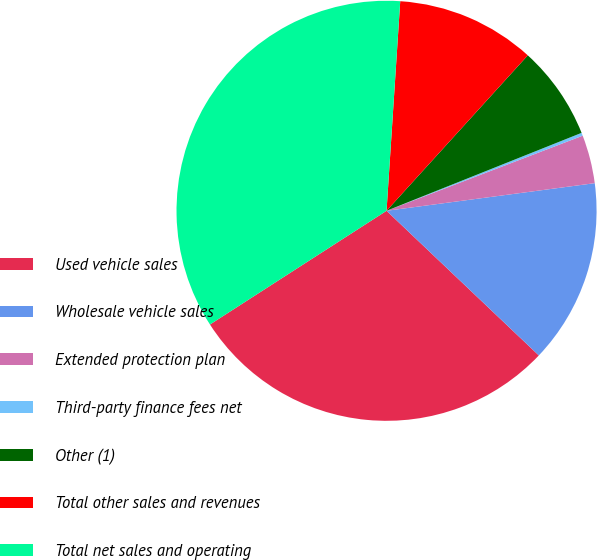<chart> <loc_0><loc_0><loc_500><loc_500><pie_chart><fcel>Used vehicle sales<fcel>Wholesale vehicle sales<fcel>Extended protection plan<fcel>Third-party finance fees net<fcel>Other (1)<fcel>Total other sales and revenues<fcel>Total net sales and operating<nl><fcel>28.8%<fcel>14.19%<fcel>3.72%<fcel>0.23%<fcel>7.21%<fcel>10.7%<fcel>35.14%<nl></chart> 